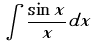Convert formula to latex. <formula><loc_0><loc_0><loc_500><loc_500>\int \frac { \sin x } { x } d x</formula> 